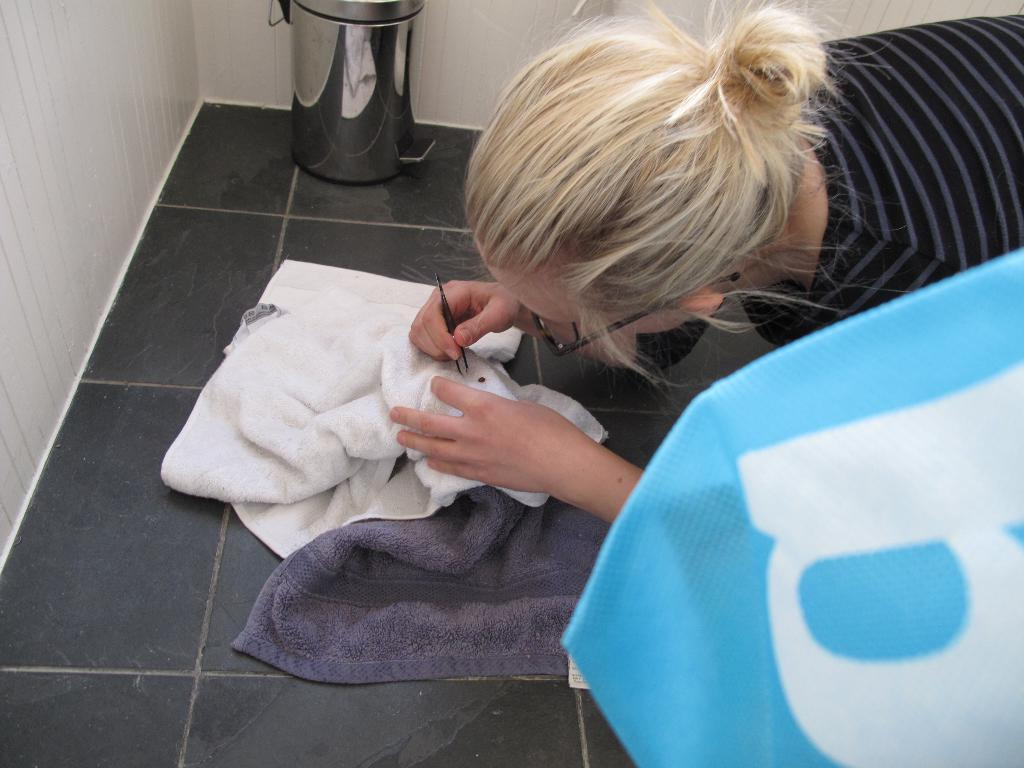Provide a one-sentence caption for the provided image. A woman is using tweezers on a towel near a bag with a B. 